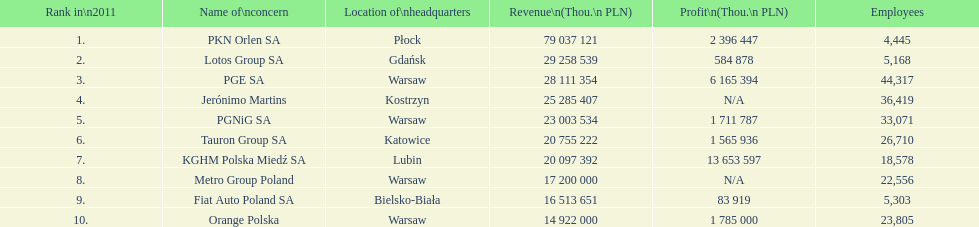Give me the full table as a dictionary. {'header': ['Rank in\\n2011', 'Name of\\nconcern', 'Location of\\nheadquarters', 'Revenue\\n(Thou.\\n\xa0PLN)', 'Profit\\n(Thou.\\n\xa0PLN)', 'Employees'], 'rows': [['1.', 'PKN Orlen SA', 'Płock', '79 037 121', '2 396 447', '4,445'], ['2.', 'Lotos Group SA', 'Gdańsk', '29 258 539', '584 878', '5,168'], ['3.', 'PGE SA', 'Warsaw', '28 111 354', '6 165 394', '44,317'], ['4.', 'Jerónimo Martins', 'Kostrzyn', '25 285 407', 'N/A', '36,419'], ['5.', 'PGNiG SA', 'Warsaw', '23 003 534', '1 711 787', '33,071'], ['6.', 'Tauron Group SA', 'Katowice', '20 755 222', '1 565 936', '26,710'], ['7.', 'KGHM Polska Miedź SA', 'Lubin', '20 097 392', '13 653 597', '18,578'], ['8.', 'Metro Group Poland', 'Warsaw', '17 200 000', 'N/A', '22,556'], ['9.', 'Fiat Auto Poland SA', 'Bielsko-Biała', '16 513 651', '83 919', '5,303'], ['10.', 'Orange Polska', 'Warsaw', '14 922 000', '1 785 000', '23,805']]} What company has the top number of employees? PGE SA. 